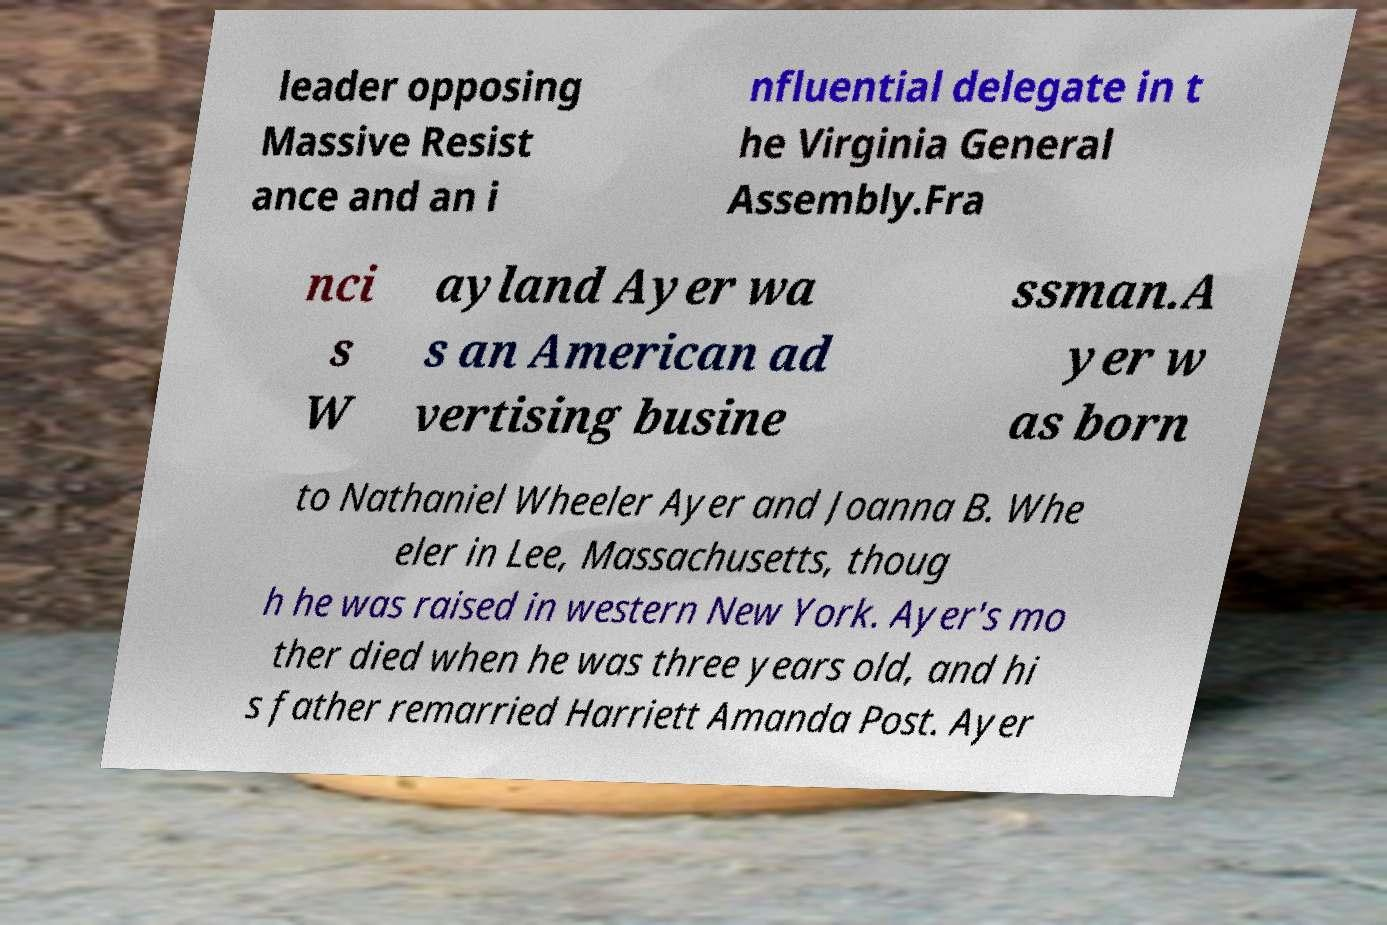I need the written content from this picture converted into text. Can you do that? leader opposing Massive Resist ance and an i nfluential delegate in t he Virginia General Assembly.Fra nci s W ayland Ayer wa s an American ad vertising busine ssman.A yer w as born to Nathaniel Wheeler Ayer and Joanna B. Whe eler in Lee, Massachusetts, thoug h he was raised in western New York. Ayer's mo ther died when he was three years old, and hi s father remarried Harriett Amanda Post. Ayer 